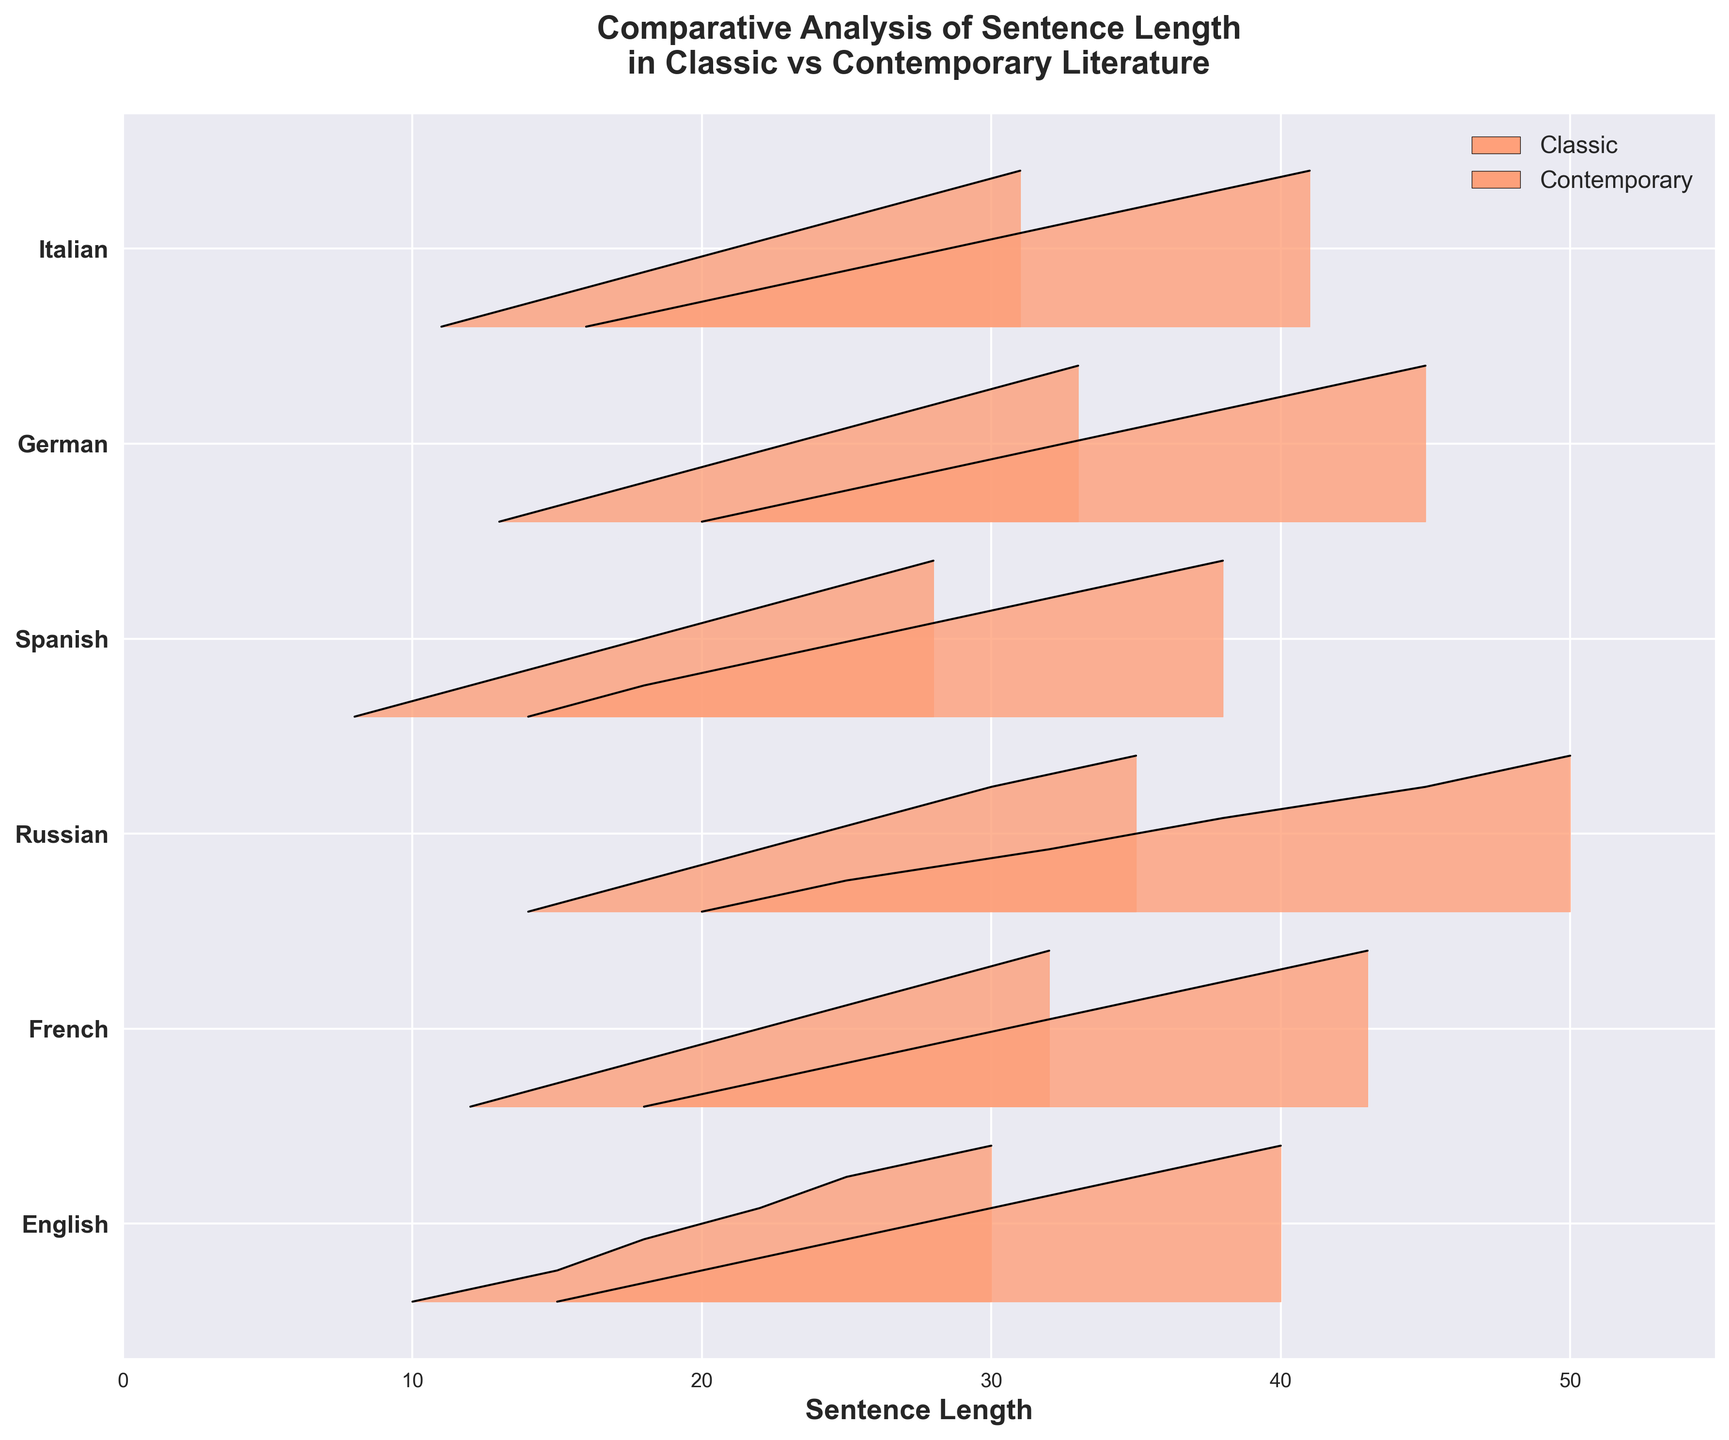What's the title of the figure? The title is usually displayed at the top of a plot. The figure title is "Comparative Analysis of Sentence Length in Classic vs Contemporary Literature".
Answer: Comparative Analysis of Sentence Length in Classic vs Contemporary Literature How many languages are analyzed in the figure? The y-axis lists the languages analyzed. By counting the labels, we can see that there are six languages: English, French, Russian, Spanish, German, and Italian.
Answer: Six Which language has the longest average sentence length in classic literature? For each language under the "Classic" category, we look at the peak point of their ridgeline distribution on the x-axis. Russian has the highest peak at 32, indicating the longest average sentence length.
Answer: Russian Which era generally has shorter sentences, classic or contemporary? By observing the position of peaks along the x-axis, we can see that for all languages, the peaks of contemporary distributions are to the left of the classic distributions, indicating shorter sentences.
Answer: Contemporary Are there any languages where contemporary sentence lengths are longer than classic? By comparing the positions of the peaks on the x-axis for each language between classic and contemporary, it's evident that in all cases, contemporary sentence lengths are shorter. So there are no languages where contemporary sentence lengths are longer.
Answer: No What's the range of sentence lengths for contemporary English literature? The range can be determined by looking for the minimum and maximum values of the x-axis for the contemporary English distribution. It ranges from about 10 to 30.
Answer: 10 to 30 For which language is the difference between average sentence lengths of classic and contemporary literature the largest? By calculating the difference for each language: English (25-18=7), French (28-20=8), Russian (32-22=10), Spanish (23-16=7), German (30-21=9), Italian (26-19=7), Russian has the largest difference of 10.
Answer: Russian How do the distributions of sentence lengths look different between classic and contemporary French literature? For French, the classic distribution peaks at a higher value and the curve is wider compared to the contemporary, which peaks lower and has a narrower curve, indicating that classic has longer and more variable sentence lengths.
Answer: Classic has longer and more variable sentence lengths Which language has the smallest average sentence length in contemporary literature? By looking at the peaks of the contemporary distributions on the x-axis, Spanish has the lowest peak at around 16.
Answer: Spanish 